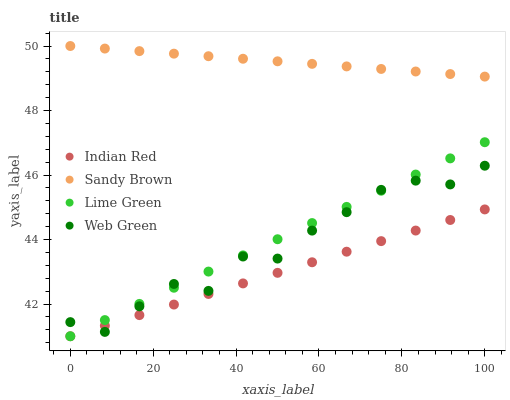Does Indian Red have the minimum area under the curve?
Answer yes or no. Yes. Does Sandy Brown have the maximum area under the curve?
Answer yes or no. Yes. Does Web Green have the minimum area under the curve?
Answer yes or no. No. Does Web Green have the maximum area under the curve?
Answer yes or no. No. Is Indian Red the smoothest?
Answer yes or no. Yes. Is Web Green the roughest?
Answer yes or no. Yes. Is Sandy Brown the smoothest?
Answer yes or no. No. Is Sandy Brown the roughest?
Answer yes or no. No. Does Lime Green have the lowest value?
Answer yes or no. Yes. Does Web Green have the lowest value?
Answer yes or no. No. Does Sandy Brown have the highest value?
Answer yes or no. Yes. Does Web Green have the highest value?
Answer yes or no. No. Is Web Green less than Sandy Brown?
Answer yes or no. Yes. Is Sandy Brown greater than Indian Red?
Answer yes or no. Yes. Does Indian Red intersect Web Green?
Answer yes or no. Yes. Is Indian Red less than Web Green?
Answer yes or no. No. Is Indian Red greater than Web Green?
Answer yes or no. No. Does Web Green intersect Sandy Brown?
Answer yes or no. No. 